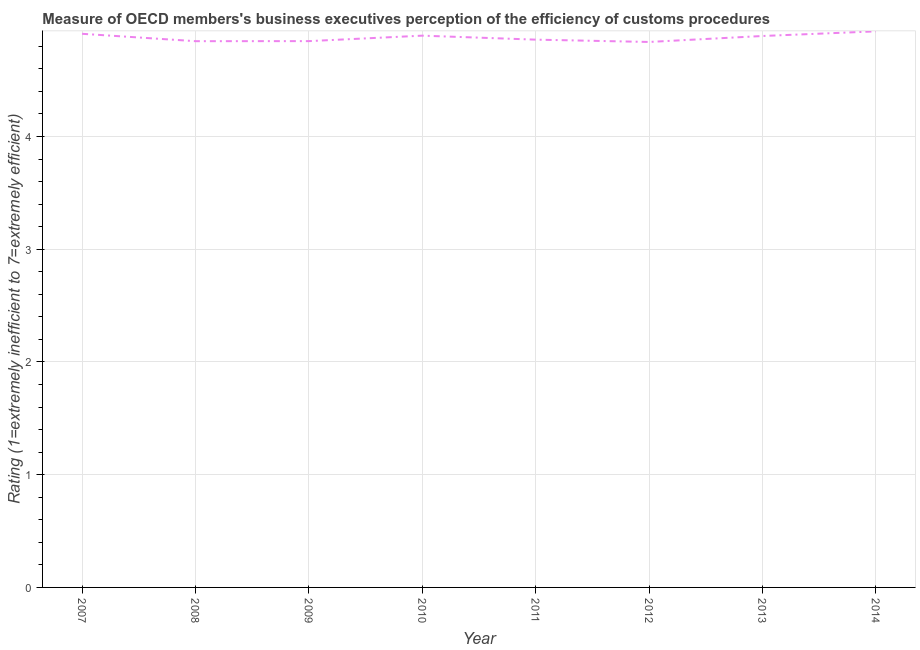What is the rating measuring burden of customs procedure in 2012?
Your response must be concise. 4.84. Across all years, what is the maximum rating measuring burden of customs procedure?
Your response must be concise. 4.93. Across all years, what is the minimum rating measuring burden of customs procedure?
Keep it short and to the point. 4.84. In which year was the rating measuring burden of customs procedure minimum?
Provide a short and direct response. 2012. What is the sum of the rating measuring burden of customs procedure?
Make the answer very short. 39.02. What is the difference between the rating measuring burden of customs procedure in 2009 and 2012?
Give a very brief answer. 0.01. What is the average rating measuring burden of customs procedure per year?
Offer a terse response. 4.88. What is the median rating measuring burden of customs procedure?
Offer a terse response. 4.88. What is the ratio of the rating measuring burden of customs procedure in 2013 to that in 2014?
Ensure brevity in your answer.  0.99. Is the rating measuring burden of customs procedure in 2009 less than that in 2013?
Make the answer very short. Yes. Is the difference between the rating measuring burden of customs procedure in 2008 and 2010 greater than the difference between any two years?
Offer a very short reply. No. What is the difference between the highest and the second highest rating measuring burden of customs procedure?
Your answer should be compact. 0.02. What is the difference between the highest and the lowest rating measuring burden of customs procedure?
Ensure brevity in your answer.  0.09. In how many years, is the rating measuring burden of customs procedure greater than the average rating measuring burden of customs procedure taken over all years?
Ensure brevity in your answer.  4. How many lines are there?
Make the answer very short. 1. What is the difference between two consecutive major ticks on the Y-axis?
Provide a short and direct response. 1. Are the values on the major ticks of Y-axis written in scientific E-notation?
Make the answer very short. No. Does the graph contain any zero values?
Offer a terse response. No. Does the graph contain grids?
Make the answer very short. Yes. What is the title of the graph?
Provide a succinct answer. Measure of OECD members's business executives perception of the efficiency of customs procedures. What is the label or title of the X-axis?
Your answer should be very brief. Year. What is the label or title of the Y-axis?
Offer a very short reply. Rating (1=extremely inefficient to 7=extremely efficient). What is the Rating (1=extremely inefficient to 7=extremely efficient) of 2007?
Offer a very short reply. 4.91. What is the Rating (1=extremely inefficient to 7=extremely efficient) in 2008?
Your answer should be very brief. 4.85. What is the Rating (1=extremely inefficient to 7=extremely efficient) of 2009?
Give a very brief answer. 4.85. What is the Rating (1=extremely inefficient to 7=extremely efficient) in 2010?
Provide a succinct answer. 4.89. What is the Rating (1=extremely inefficient to 7=extremely efficient) of 2011?
Your response must be concise. 4.86. What is the Rating (1=extremely inefficient to 7=extremely efficient) in 2012?
Your answer should be compact. 4.84. What is the Rating (1=extremely inefficient to 7=extremely efficient) in 2013?
Your response must be concise. 4.89. What is the Rating (1=extremely inefficient to 7=extremely efficient) of 2014?
Your response must be concise. 4.93. What is the difference between the Rating (1=extremely inefficient to 7=extremely efficient) in 2007 and 2008?
Ensure brevity in your answer.  0.07. What is the difference between the Rating (1=extremely inefficient to 7=extremely efficient) in 2007 and 2009?
Offer a very short reply. 0.07. What is the difference between the Rating (1=extremely inefficient to 7=extremely efficient) in 2007 and 2010?
Your response must be concise. 0.02. What is the difference between the Rating (1=extremely inefficient to 7=extremely efficient) in 2007 and 2011?
Offer a terse response. 0.05. What is the difference between the Rating (1=extremely inefficient to 7=extremely efficient) in 2007 and 2012?
Make the answer very short. 0.07. What is the difference between the Rating (1=extremely inefficient to 7=extremely efficient) in 2007 and 2013?
Ensure brevity in your answer.  0.02. What is the difference between the Rating (1=extremely inefficient to 7=extremely efficient) in 2007 and 2014?
Provide a succinct answer. -0.02. What is the difference between the Rating (1=extremely inefficient to 7=extremely efficient) in 2008 and 2009?
Ensure brevity in your answer.  -0. What is the difference between the Rating (1=extremely inefficient to 7=extremely efficient) in 2008 and 2010?
Keep it short and to the point. -0.05. What is the difference between the Rating (1=extremely inefficient to 7=extremely efficient) in 2008 and 2011?
Give a very brief answer. -0.01. What is the difference between the Rating (1=extremely inefficient to 7=extremely efficient) in 2008 and 2012?
Provide a succinct answer. 0.01. What is the difference between the Rating (1=extremely inefficient to 7=extremely efficient) in 2008 and 2013?
Offer a terse response. -0.05. What is the difference between the Rating (1=extremely inefficient to 7=extremely efficient) in 2008 and 2014?
Your response must be concise. -0.09. What is the difference between the Rating (1=extremely inefficient to 7=extremely efficient) in 2009 and 2010?
Keep it short and to the point. -0.05. What is the difference between the Rating (1=extremely inefficient to 7=extremely efficient) in 2009 and 2011?
Offer a very short reply. -0.01. What is the difference between the Rating (1=extremely inefficient to 7=extremely efficient) in 2009 and 2012?
Provide a short and direct response. 0.01. What is the difference between the Rating (1=extremely inefficient to 7=extremely efficient) in 2009 and 2013?
Your answer should be very brief. -0.05. What is the difference between the Rating (1=extremely inefficient to 7=extremely efficient) in 2009 and 2014?
Ensure brevity in your answer.  -0.09. What is the difference between the Rating (1=extremely inefficient to 7=extremely efficient) in 2010 and 2011?
Your answer should be very brief. 0.04. What is the difference between the Rating (1=extremely inefficient to 7=extremely efficient) in 2010 and 2012?
Offer a terse response. 0.06. What is the difference between the Rating (1=extremely inefficient to 7=extremely efficient) in 2010 and 2013?
Ensure brevity in your answer.  0. What is the difference between the Rating (1=extremely inefficient to 7=extremely efficient) in 2010 and 2014?
Your answer should be very brief. -0.04. What is the difference between the Rating (1=extremely inefficient to 7=extremely efficient) in 2011 and 2012?
Offer a terse response. 0.02. What is the difference between the Rating (1=extremely inefficient to 7=extremely efficient) in 2011 and 2013?
Offer a terse response. -0.03. What is the difference between the Rating (1=extremely inefficient to 7=extremely efficient) in 2011 and 2014?
Your response must be concise. -0.07. What is the difference between the Rating (1=extremely inefficient to 7=extremely efficient) in 2012 and 2013?
Your answer should be very brief. -0.05. What is the difference between the Rating (1=extremely inefficient to 7=extremely efficient) in 2012 and 2014?
Your response must be concise. -0.09. What is the difference between the Rating (1=extremely inefficient to 7=extremely efficient) in 2013 and 2014?
Give a very brief answer. -0.04. What is the ratio of the Rating (1=extremely inefficient to 7=extremely efficient) in 2007 to that in 2008?
Provide a succinct answer. 1.01. What is the ratio of the Rating (1=extremely inefficient to 7=extremely efficient) in 2007 to that in 2009?
Ensure brevity in your answer.  1.01. What is the ratio of the Rating (1=extremely inefficient to 7=extremely efficient) in 2007 to that in 2011?
Keep it short and to the point. 1.01. What is the ratio of the Rating (1=extremely inefficient to 7=extremely efficient) in 2007 to that in 2012?
Provide a succinct answer. 1.01. What is the ratio of the Rating (1=extremely inefficient to 7=extremely efficient) in 2008 to that in 2011?
Provide a short and direct response. 1. What is the ratio of the Rating (1=extremely inefficient to 7=extremely efficient) in 2008 to that in 2012?
Give a very brief answer. 1. What is the ratio of the Rating (1=extremely inefficient to 7=extremely efficient) in 2008 to that in 2013?
Provide a succinct answer. 0.99. What is the ratio of the Rating (1=extremely inefficient to 7=extremely efficient) in 2009 to that in 2010?
Your answer should be very brief. 0.99. What is the ratio of the Rating (1=extremely inefficient to 7=extremely efficient) in 2009 to that in 2012?
Offer a terse response. 1. What is the ratio of the Rating (1=extremely inefficient to 7=extremely efficient) in 2009 to that in 2014?
Provide a short and direct response. 0.98. What is the ratio of the Rating (1=extremely inefficient to 7=extremely efficient) in 2010 to that in 2014?
Provide a succinct answer. 0.99. What is the ratio of the Rating (1=extremely inefficient to 7=extremely efficient) in 2011 to that in 2012?
Ensure brevity in your answer.  1. What is the ratio of the Rating (1=extremely inefficient to 7=extremely efficient) in 2012 to that in 2013?
Ensure brevity in your answer.  0.99. 